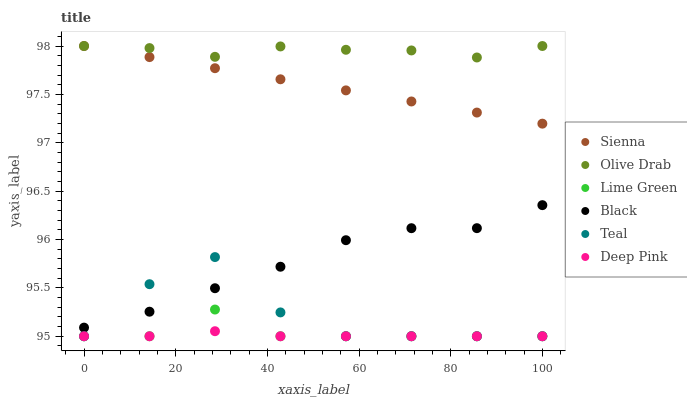Does Deep Pink have the minimum area under the curve?
Answer yes or no. Yes. Does Olive Drab have the maximum area under the curve?
Answer yes or no. Yes. Does Sienna have the minimum area under the curve?
Answer yes or no. No. Does Sienna have the maximum area under the curve?
Answer yes or no. No. Is Sienna the smoothest?
Answer yes or no. Yes. Is Teal the roughest?
Answer yes or no. Yes. Is Black the smoothest?
Answer yes or no. No. Is Black the roughest?
Answer yes or no. No. Does Deep Pink have the lowest value?
Answer yes or no. Yes. Does Sienna have the lowest value?
Answer yes or no. No. Does Olive Drab have the highest value?
Answer yes or no. Yes. Does Black have the highest value?
Answer yes or no. No. Is Deep Pink less than Sienna?
Answer yes or no. Yes. Is Sienna greater than Teal?
Answer yes or no. Yes. Does Deep Pink intersect Teal?
Answer yes or no. Yes. Is Deep Pink less than Teal?
Answer yes or no. No. Is Deep Pink greater than Teal?
Answer yes or no. No. Does Deep Pink intersect Sienna?
Answer yes or no. No. 